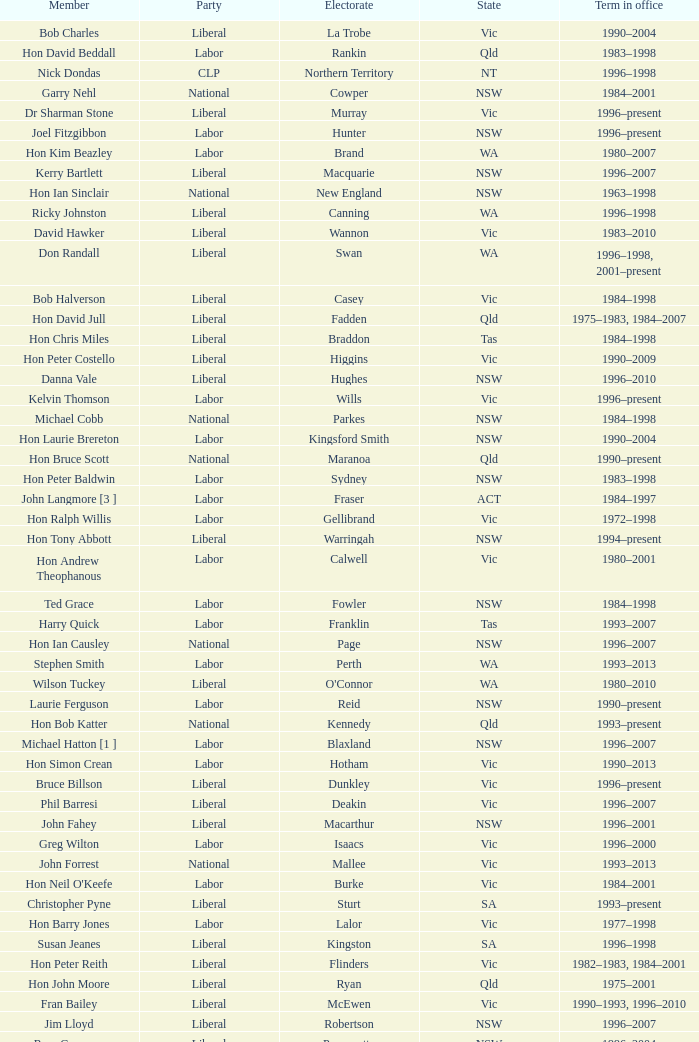What state did Hon David Beddall belong to? Qld. 